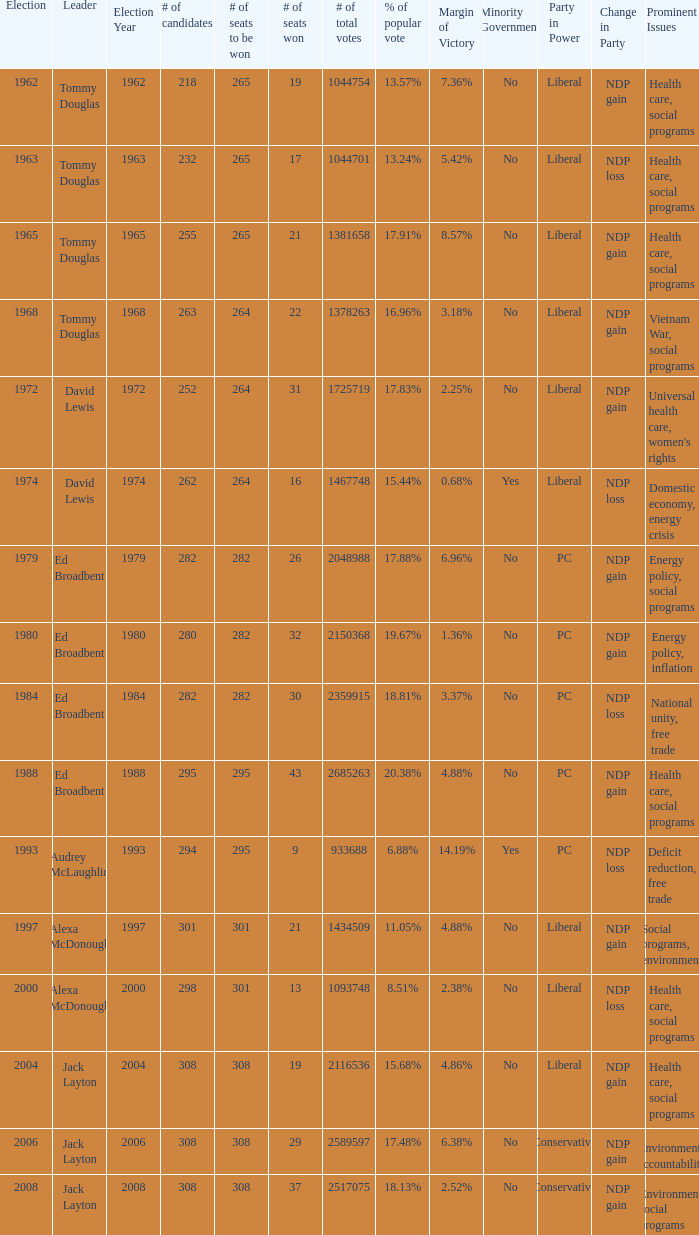Name the number of candidates for # of seats won being 43 295.0. 